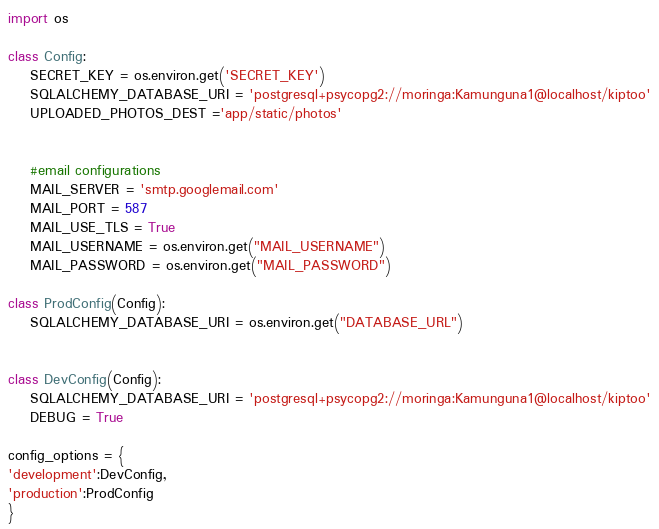<code> <loc_0><loc_0><loc_500><loc_500><_Python_>import os

class Config:
    SECRET_KEY = os.environ.get('SECRET_KEY')
    SQLALCHEMY_DATABASE_URI = 'postgresql+psycopg2://moringa:Kamunguna1@localhost/kiptoo'
    UPLOADED_PHOTOS_DEST ='app/static/photos'


    #email configurations
    MAIL_SERVER = 'smtp.googlemail.com'
    MAIL_PORT = 587
    MAIL_USE_TLS = True
    MAIL_USERNAME = os.environ.get("MAIL_USERNAME")
    MAIL_PASSWORD = os.environ.get("MAIL_PASSWORD")

class ProdConfig(Config):
    SQLALCHEMY_DATABASE_URI = os.environ.get("DATABASE_URL")


class DevConfig(Config):
    SQLALCHEMY_DATABASE_URI = 'postgresql+psycopg2://moringa:Kamunguna1@localhost/kiptoo'
    DEBUG = True

config_options = {
'development':DevConfig,
'production':ProdConfig
}</code> 